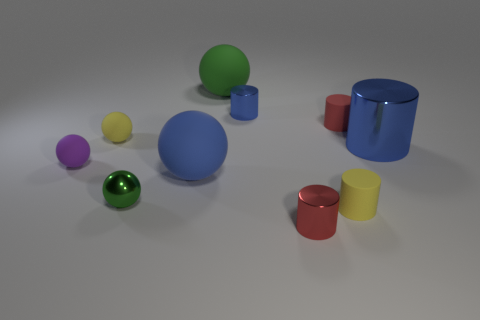There is a tiny metal thing that is to the right of the blue object behind the red rubber thing; what number of blue cylinders are to the right of it?
Your answer should be very brief. 1. How many things are yellow matte cylinders or large rubber things?
Offer a very short reply. 3. There is a purple rubber object; is it the same shape as the tiny yellow object left of the small green ball?
Give a very brief answer. Yes. There is a small yellow object behind the small yellow cylinder; what is its shape?
Make the answer very short. Sphere. Does the purple matte object have the same shape as the large green matte object?
Your answer should be compact. Yes. The blue matte object that is the same shape as the small purple object is what size?
Provide a short and direct response. Large. There is a green object right of the blue ball; is its size the same as the small blue metal cylinder?
Your answer should be very brief. No. There is a metal cylinder that is behind the green shiny object and on the left side of the tiny yellow matte cylinder; what size is it?
Your answer should be compact. Small. There is a small cylinder that is the same color as the large cylinder; what is it made of?
Your answer should be very brief. Metal. What number of tiny rubber cylinders are the same color as the metallic ball?
Give a very brief answer. 0. 